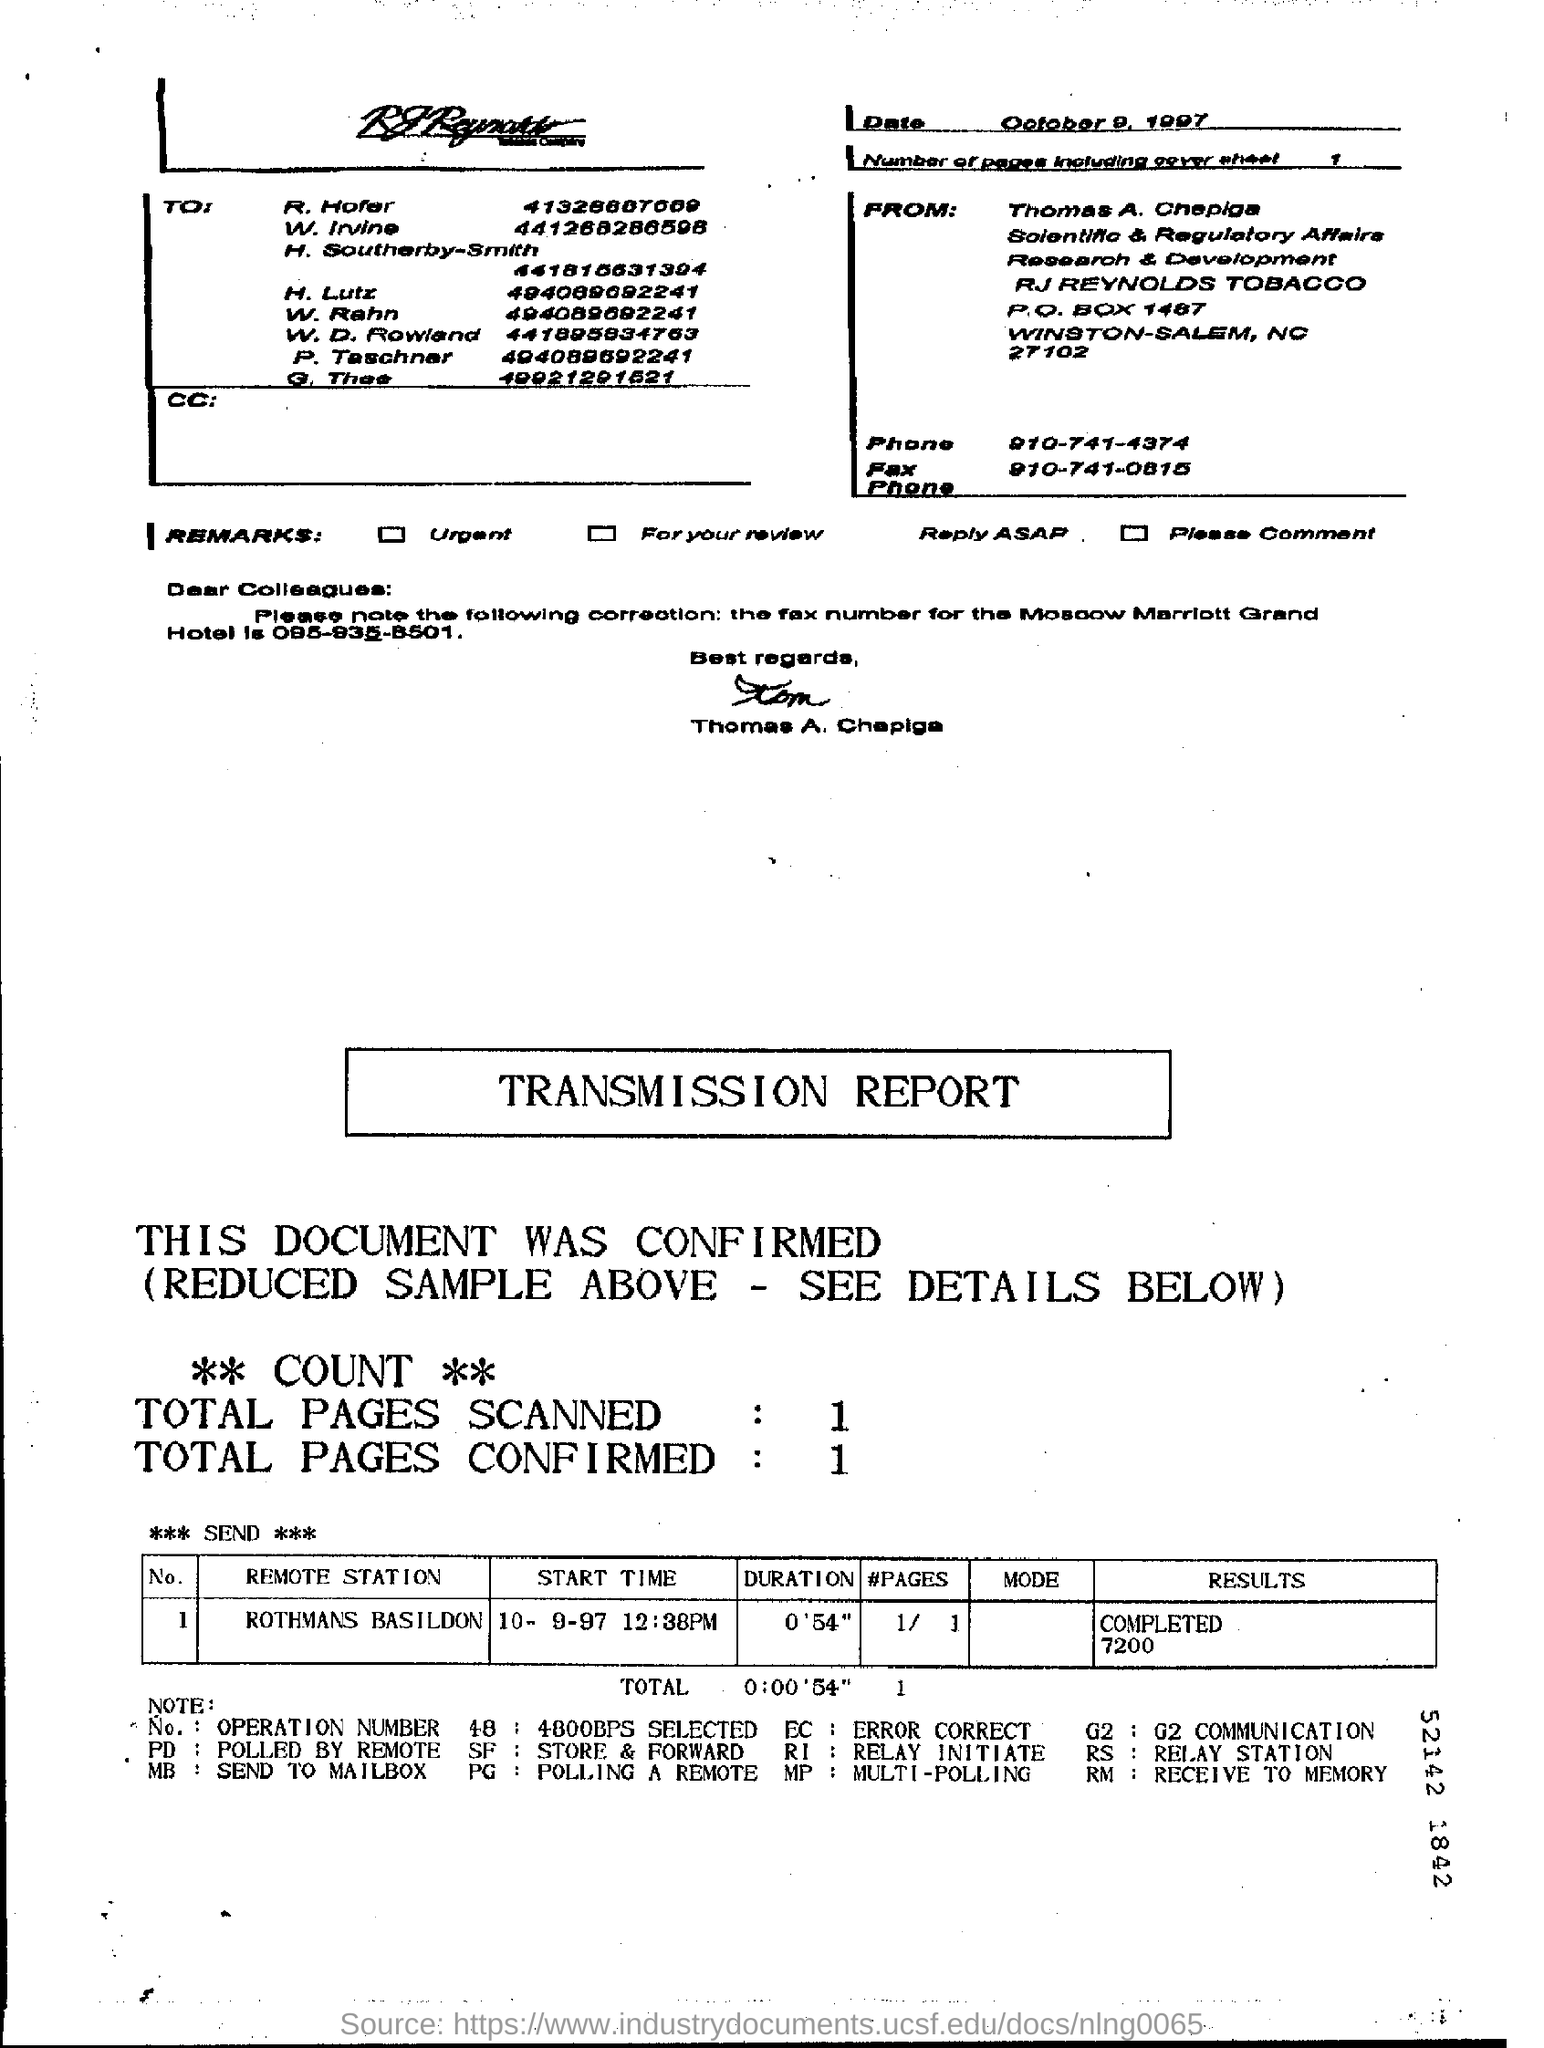Specify some key components in this picture. The name of the remote station is Rothmans Basildon. I'm sorry, I'm not sure what you are trying to say. Can you please provide more context or clarify your question? The corrected fax number for the Moscow Marriott Grand Hotel is 095-935-8501. 